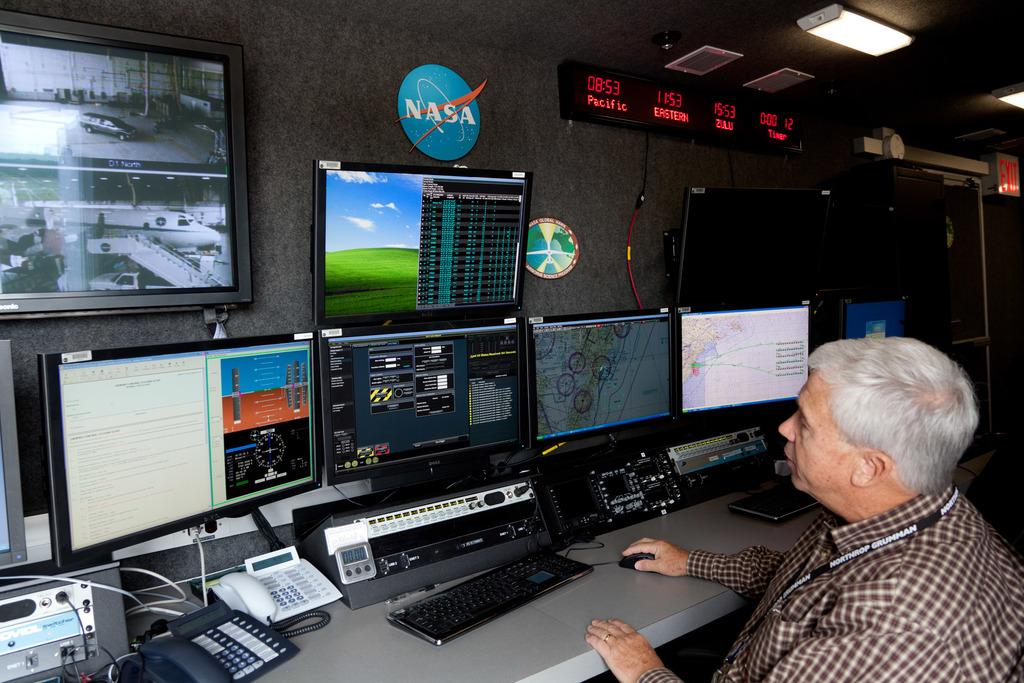<image>
Describe the image concisely. A man with grey hair is operating a computer station that says NASA above it. 